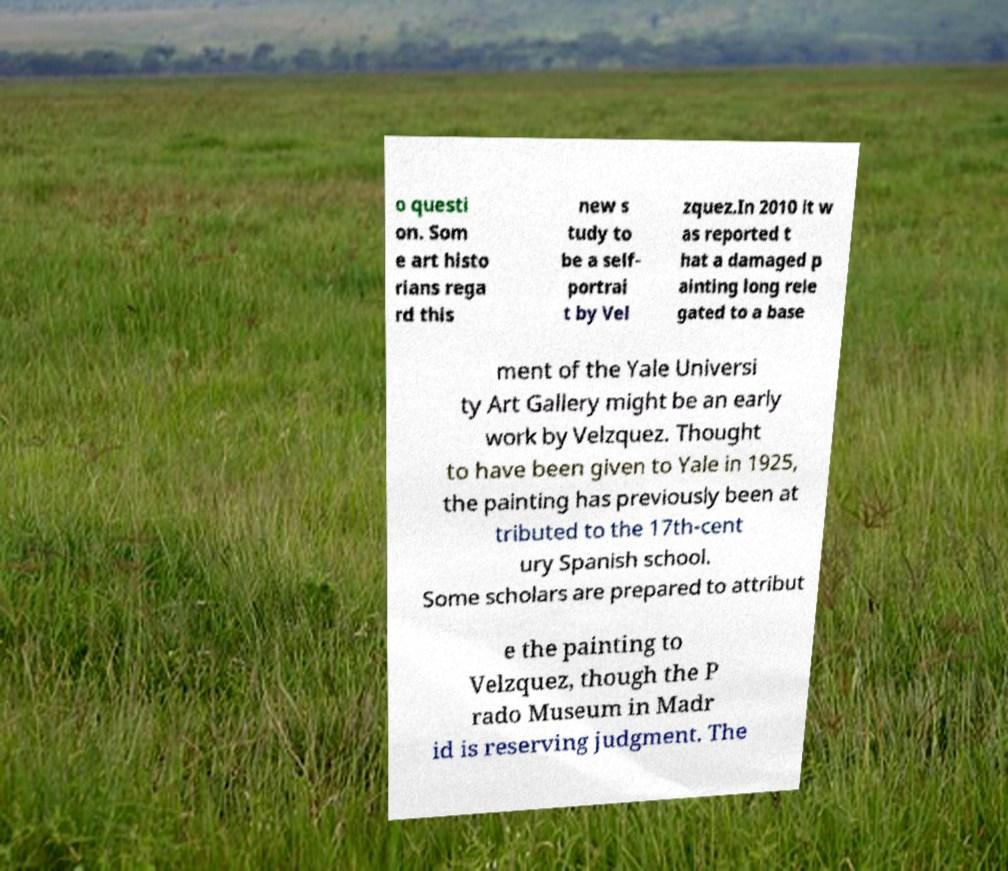Please read and relay the text visible in this image. What does it say? o questi on. Som e art histo rians rega rd this new s tudy to be a self- portrai t by Vel zquez.In 2010 it w as reported t hat a damaged p ainting long rele gated to a base ment of the Yale Universi ty Art Gallery might be an early work by Velzquez. Thought to have been given to Yale in 1925, the painting has previously been at tributed to the 17th-cent ury Spanish school. Some scholars are prepared to attribut e the painting to Velzquez, though the P rado Museum in Madr id is reserving judgment. The 